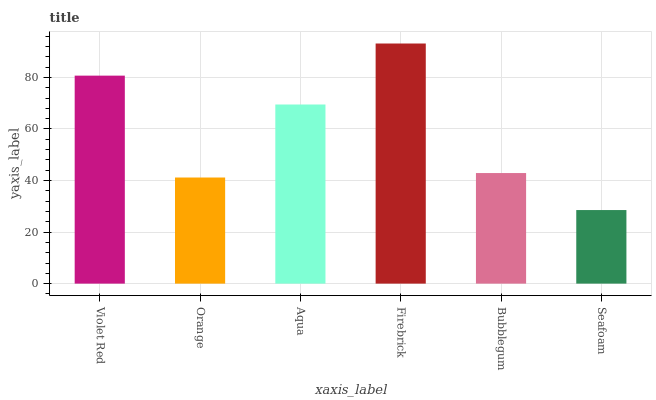Is Orange the minimum?
Answer yes or no. No. Is Orange the maximum?
Answer yes or no. No. Is Violet Red greater than Orange?
Answer yes or no. Yes. Is Orange less than Violet Red?
Answer yes or no. Yes. Is Orange greater than Violet Red?
Answer yes or no. No. Is Violet Red less than Orange?
Answer yes or no. No. Is Aqua the high median?
Answer yes or no. Yes. Is Bubblegum the low median?
Answer yes or no. Yes. Is Seafoam the high median?
Answer yes or no. No. Is Firebrick the low median?
Answer yes or no. No. 